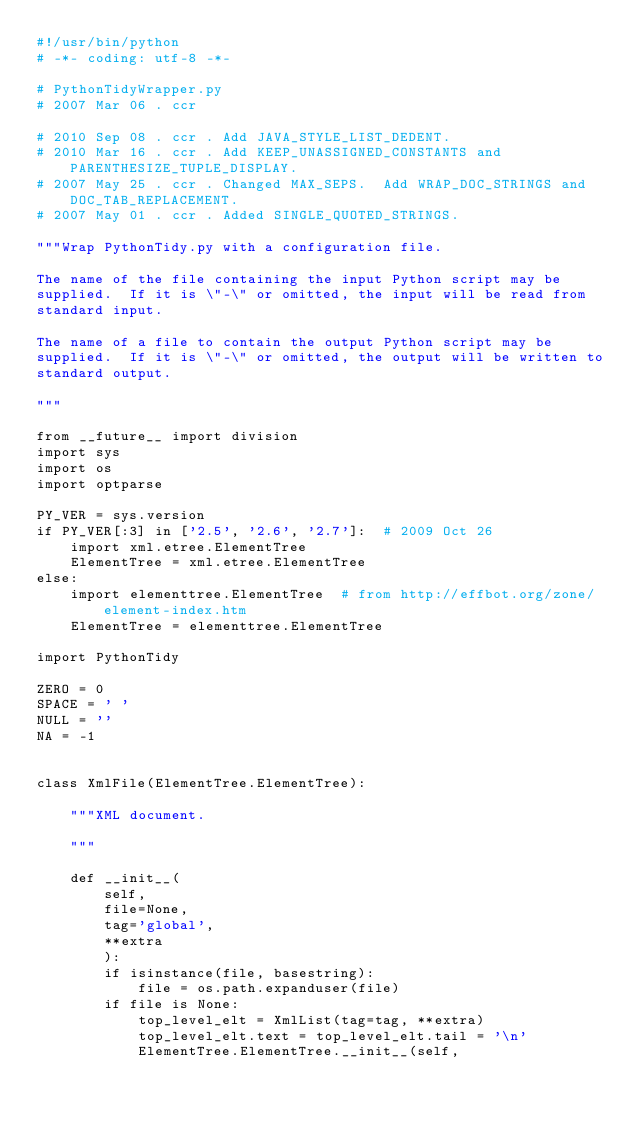Convert code to text. <code><loc_0><loc_0><loc_500><loc_500><_Python_>#!/usr/bin/python
# -*- coding: utf-8 -*-

# PythonTidyWrapper.py
# 2007 Mar 06 . ccr

# 2010 Sep 08 . ccr . Add JAVA_STYLE_LIST_DEDENT.
# 2010 Mar 16 . ccr . Add KEEP_UNASSIGNED_CONSTANTS and PARENTHESIZE_TUPLE_DISPLAY.
# 2007 May 25 . ccr . Changed MAX_SEPS.  Add WRAP_DOC_STRINGS and DOC_TAB_REPLACEMENT.
# 2007 May 01 . ccr . Added SINGLE_QUOTED_STRINGS.

"""Wrap PythonTidy.py with a configuration file.

The name of the file containing the input Python script may be
supplied.  If it is \"-\" or omitted, the input will be read from
standard input.

The name of a file to contain the output Python script may be
supplied.  If it is \"-\" or omitted, the output will be written to
standard output.

"""

from __future__ import division
import sys
import os
import optparse

PY_VER = sys.version
if PY_VER[:3] in ['2.5', '2.6', '2.7']:  # 2009 Oct 26
    import xml.etree.ElementTree
    ElementTree = xml.etree.ElementTree
else:
    import elementtree.ElementTree  # from http://effbot.org/zone/element-index.htm
    ElementTree = elementtree.ElementTree

import PythonTidy

ZERO = 0
SPACE = ' '
NULL = ''
NA = -1


class XmlFile(ElementTree.ElementTree):

    """XML document.

    """

    def __init__(
        self,
        file=None,
        tag='global',
        **extra
        ):
        if isinstance(file, basestring):
            file = os.path.expanduser(file)
        if file is None:
            top_level_elt = XmlList(tag=tag, **extra)
            top_level_elt.text = top_level_elt.tail = '\n'
            ElementTree.ElementTree.__init__(self,</code> 